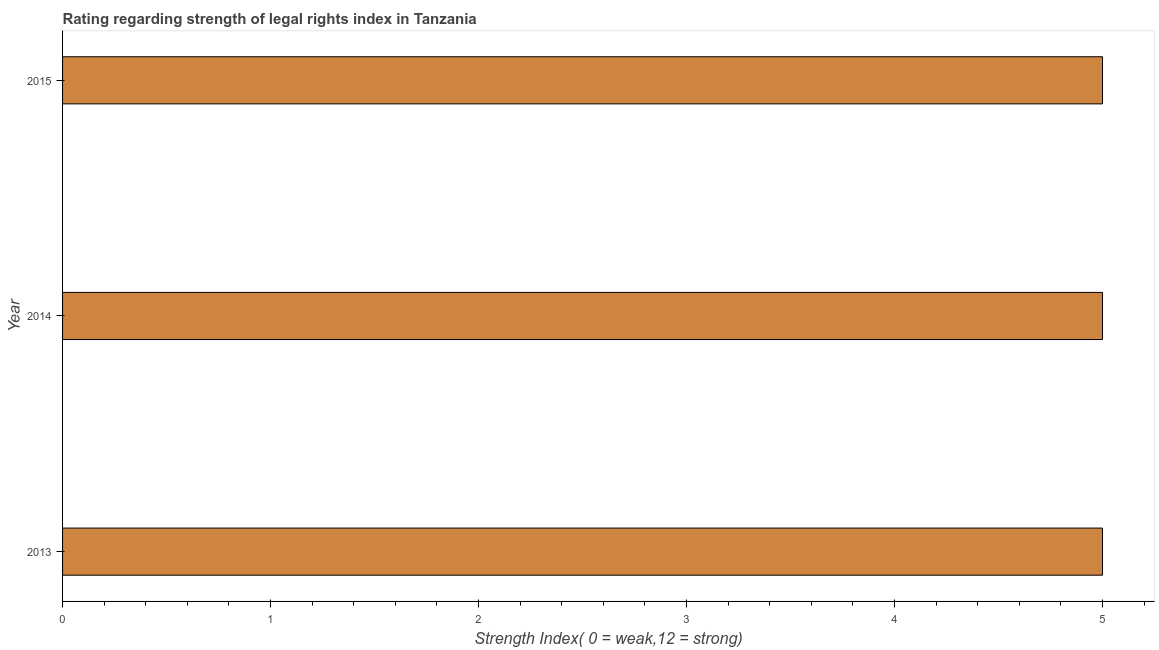Does the graph contain any zero values?
Provide a short and direct response. No. What is the title of the graph?
Provide a short and direct response. Rating regarding strength of legal rights index in Tanzania. What is the label or title of the X-axis?
Give a very brief answer. Strength Index( 0 = weak,12 = strong). What is the strength of legal rights index in 2013?
Your answer should be compact. 5. Across all years, what is the minimum strength of legal rights index?
Provide a short and direct response. 5. What is the difference between the strength of legal rights index in 2014 and 2015?
Ensure brevity in your answer.  0. What is the average strength of legal rights index per year?
Keep it short and to the point. 5. What is the median strength of legal rights index?
Keep it short and to the point. 5. Do a majority of the years between 2015 and 2013 (inclusive) have strength of legal rights index greater than 0.8 ?
Make the answer very short. Yes. What is the ratio of the strength of legal rights index in 2013 to that in 2015?
Your answer should be very brief. 1. Is the difference between the strength of legal rights index in 2013 and 2015 greater than the difference between any two years?
Your answer should be compact. Yes. What is the difference between the highest and the lowest strength of legal rights index?
Keep it short and to the point. 0. In how many years, is the strength of legal rights index greater than the average strength of legal rights index taken over all years?
Make the answer very short. 0. How many years are there in the graph?
Make the answer very short. 3. What is the difference between two consecutive major ticks on the X-axis?
Ensure brevity in your answer.  1. Are the values on the major ticks of X-axis written in scientific E-notation?
Offer a terse response. No. What is the Strength Index( 0 = weak,12 = strong) in 2013?
Ensure brevity in your answer.  5. What is the Strength Index( 0 = weak,12 = strong) of 2014?
Offer a very short reply. 5. What is the difference between the Strength Index( 0 = weak,12 = strong) in 2013 and 2014?
Your answer should be compact. 0. What is the ratio of the Strength Index( 0 = weak,12 = strong) in 2013 to that in 2015?
Your answer should be very brief. 1. What is the ratio of the Strength Index( 0 = weak,12 = strong) in 2014 to that in 2015?
Keep it short and to the point. 1. 